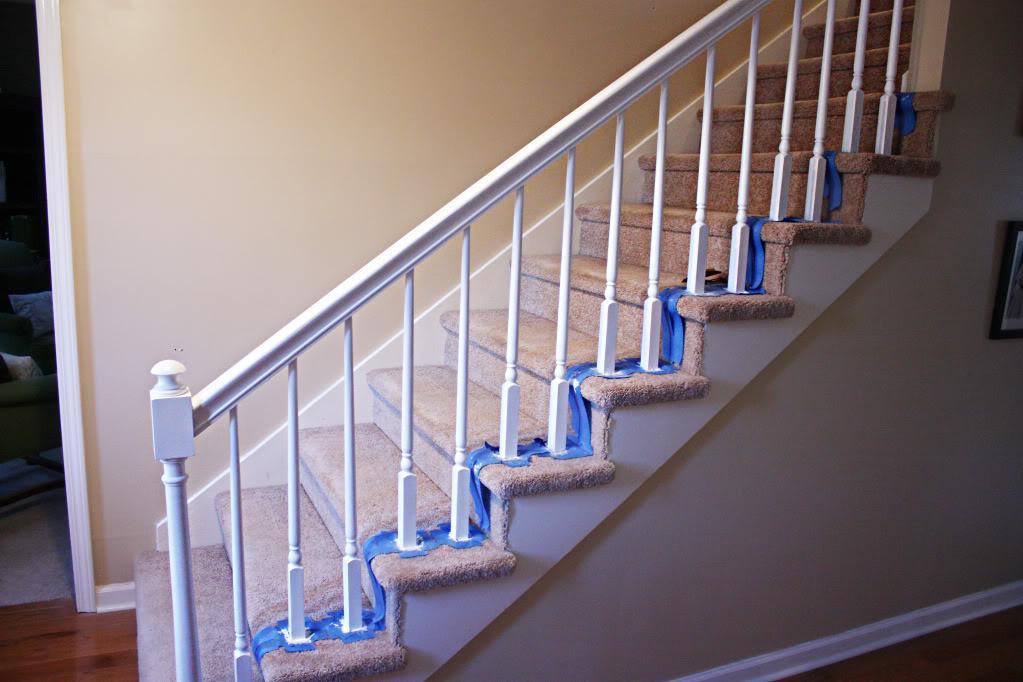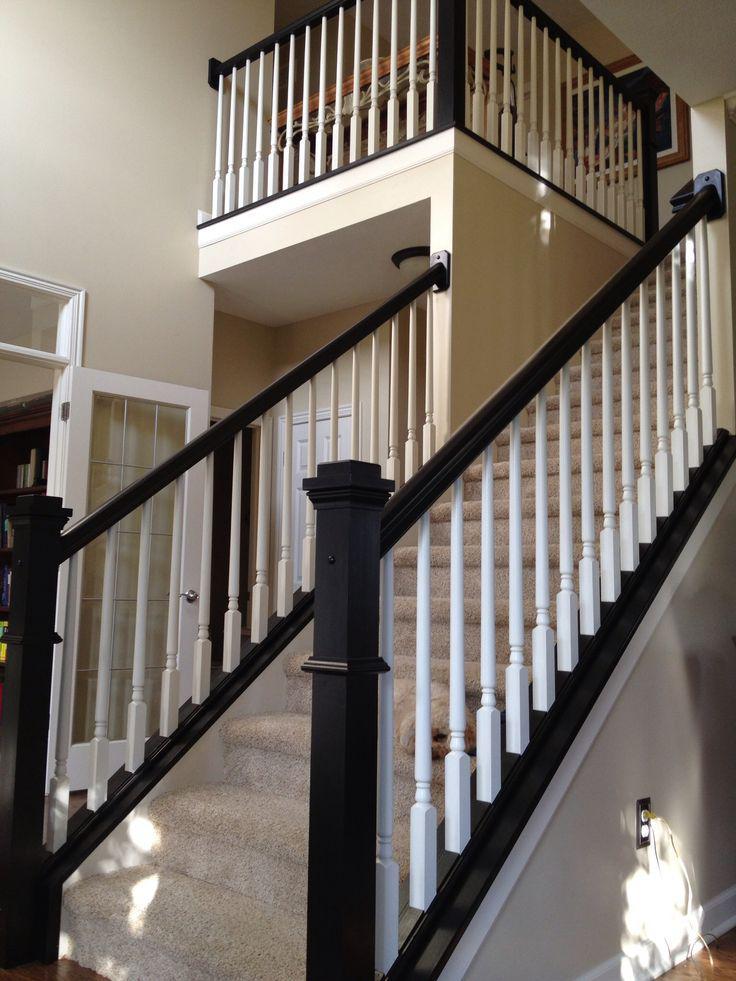The first image is the image on the left, the second image is the image on the right. Analyze the images presented: Is the assertion "The left image shows one non-turning flight of carpeted stairs, with spindle rails and a ball atop the end post." valid? Answer yes or no. Yes. The first image is the image on the left, the second image is the image on the right. Analyze the images presented: Is the assertion "there is a stairway with windows and a chandelier hanging from the ceiling" valid? Answer yes or no. No. 